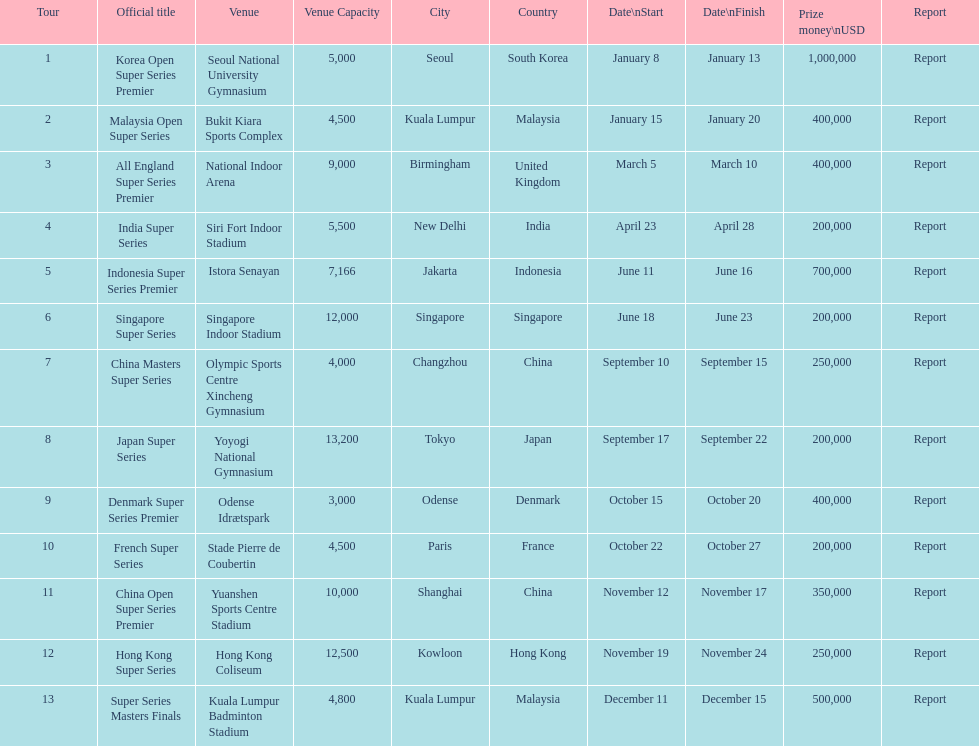How many series obtained no less than $500,000 in reward money? 3. 